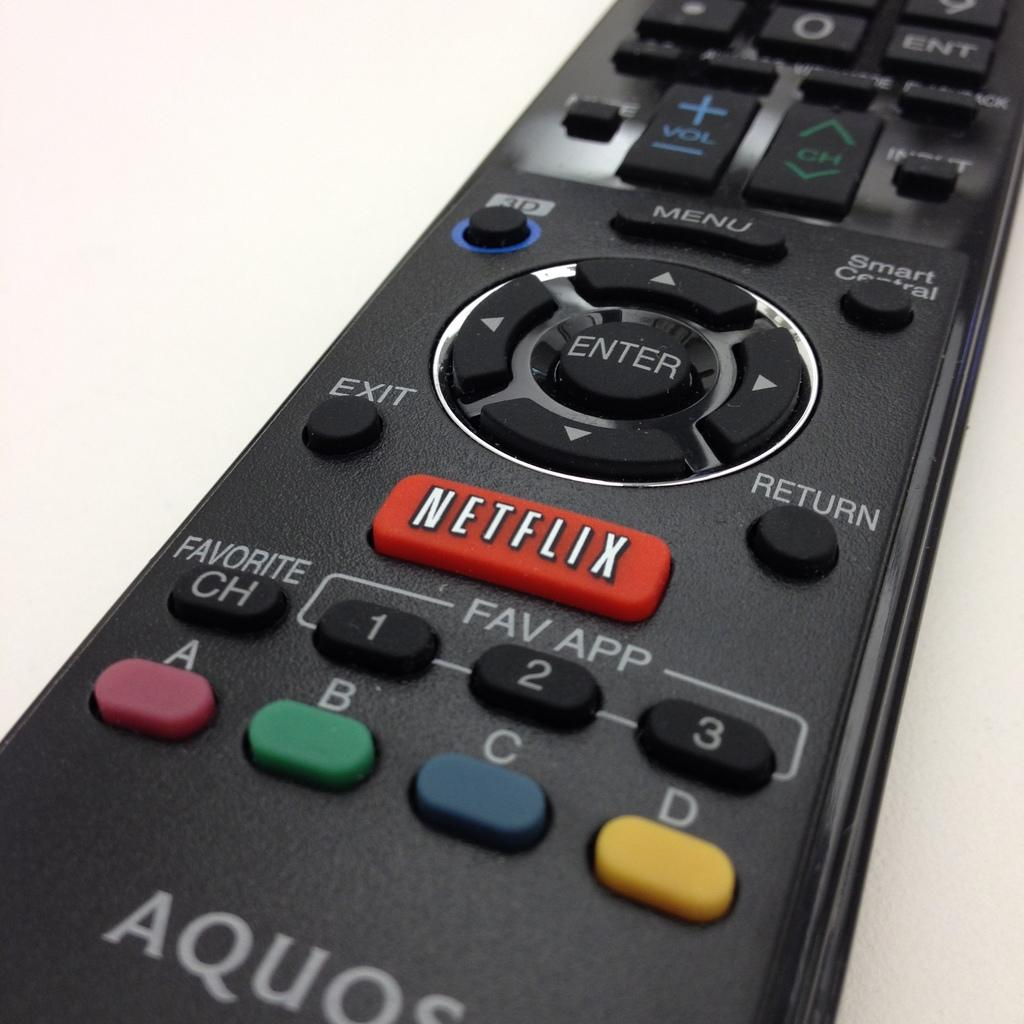<image>
Give a short and clear explanation of the subsequent image. A black Aquos remote has a red button that says Netflix. 